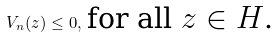Convert formula to latex. <formula><loc_0><loc_0><loc_500><loc_500>V _ { n } ( z ) \leq 0 , \, \text {for all $z\in \mathbb{ }H$.}</formula> 